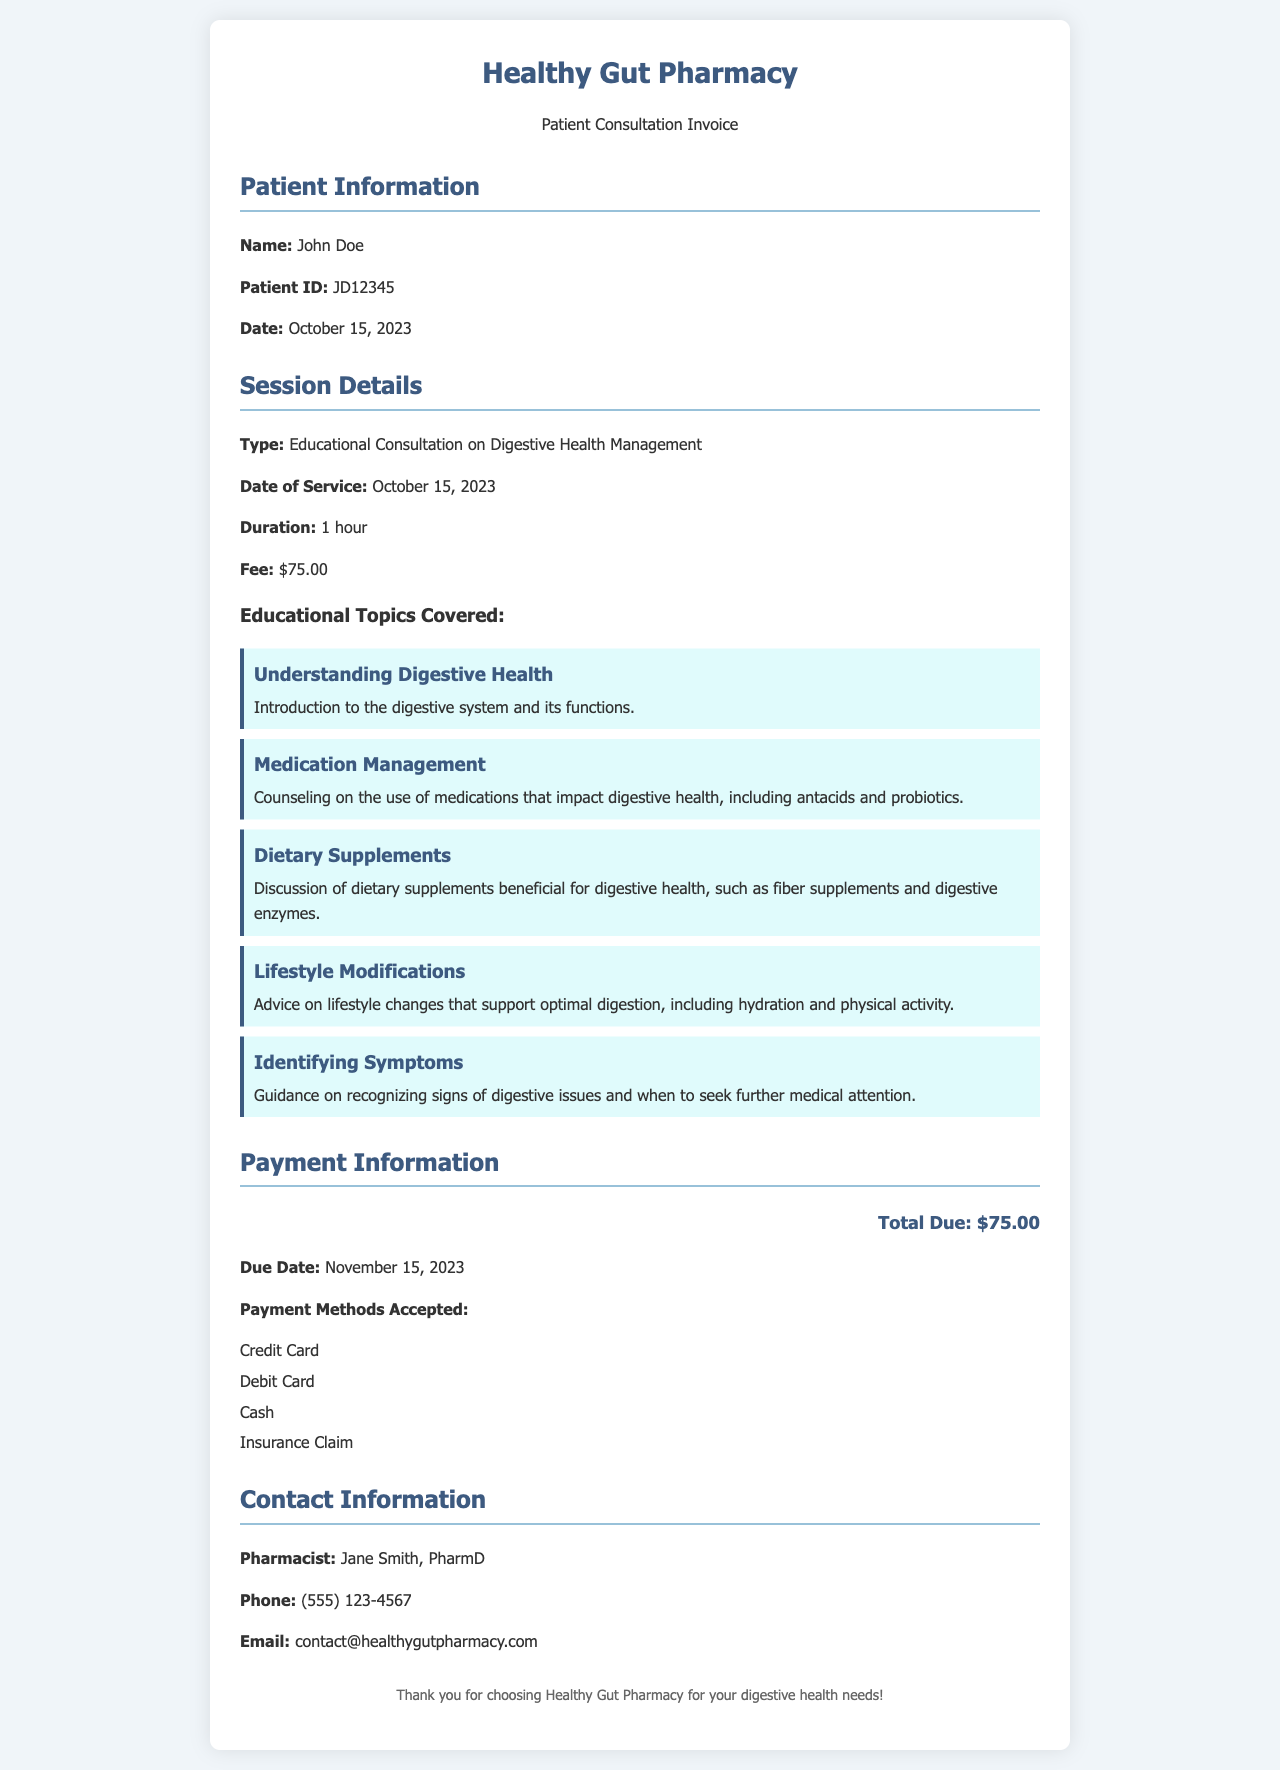What is the patient's name? The patient's name is listed in the document under Patient Information as John Doe.
Answer: John Doe What is the Patient ID? The Patient ID is specified in the document and is JD12345.
Answer: JD12345 What is the date of service? The date of service is indicated as October 15, 2023, within the Session Details.
Answer: October 15, 2023 What is the total due amount? The total due amount is provided in the Payment Information section as $75.00.
Answer: $75.00 Which educational topic addresses medications? The topic covering medications is titled "Medication Management."
Answer: Medication Management How long did the consultation last? The duration of the consultation is mentioned as 1 hour in the Session Details.
Answer: 1 hour When is the payment due date? The due date for payment is stated as November 15, 2023, in the Payment Information section.
Answer: November 15, 2023 What payment methods are accepted? The accepted payment methods are listed, including Credit Card, Debit Card, Cash, and Insurance Claim.
Answer: Credit Card, Debit Card, Cash, Insurance Claim Who is the contact pharmacist? The contact pharmacist is named Jane Smith, PharmD, listed in the Contact Information.
Answer: Jane Smith, PharmD 